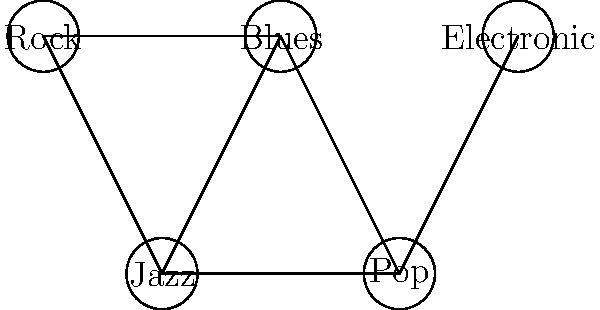In the music influence graph shown, which genre acts as a critical bridge between traditional and modern styles, and what would happen to the graph's connectivity if this genre were removed? To answer this question, we need to analyze the graph structure and the relationships between different music genres:

1. Identify the nodes: The graph shows five genres - Rock, Blues, Jazz, Pop, and Electronic.

2. Analyze the connections:
   - Rock is connected to Blues and Jazz
   - Blues is connected to Rock, Jazz, and Pop
   - Jazz is connected to Rock, Blues, and Pop
   - Pop is connected to Blues, Jazz, and Electronic
   - Electronic is connected only to Pop

3. Identify traditional and modern styles:
   - Traditional styles: Rock, Blues, Jazz
   - Modern styles: Pop, Electronic

4. Find the critical bridge:
   - Jazz acts as a bridge between traditional (Rock, Blues) and modern (Pop) styles
   - It has connections to both traditional and modern genres

5. Consider the impact of removing Jazz:
   - Without Jazz, the graph would be split into two disconnected components:
     a. Rock and Blues (traditional)
     b. Pop and Electronic (modern)

6. Conclusion:
   Jazz is the critical genre that maintains connectivity between traditional and modern styles in this influence graph. Its removal would disconnect the graph, isolating traditional from modern genres.
Answer: Jazz; graph disconnects 